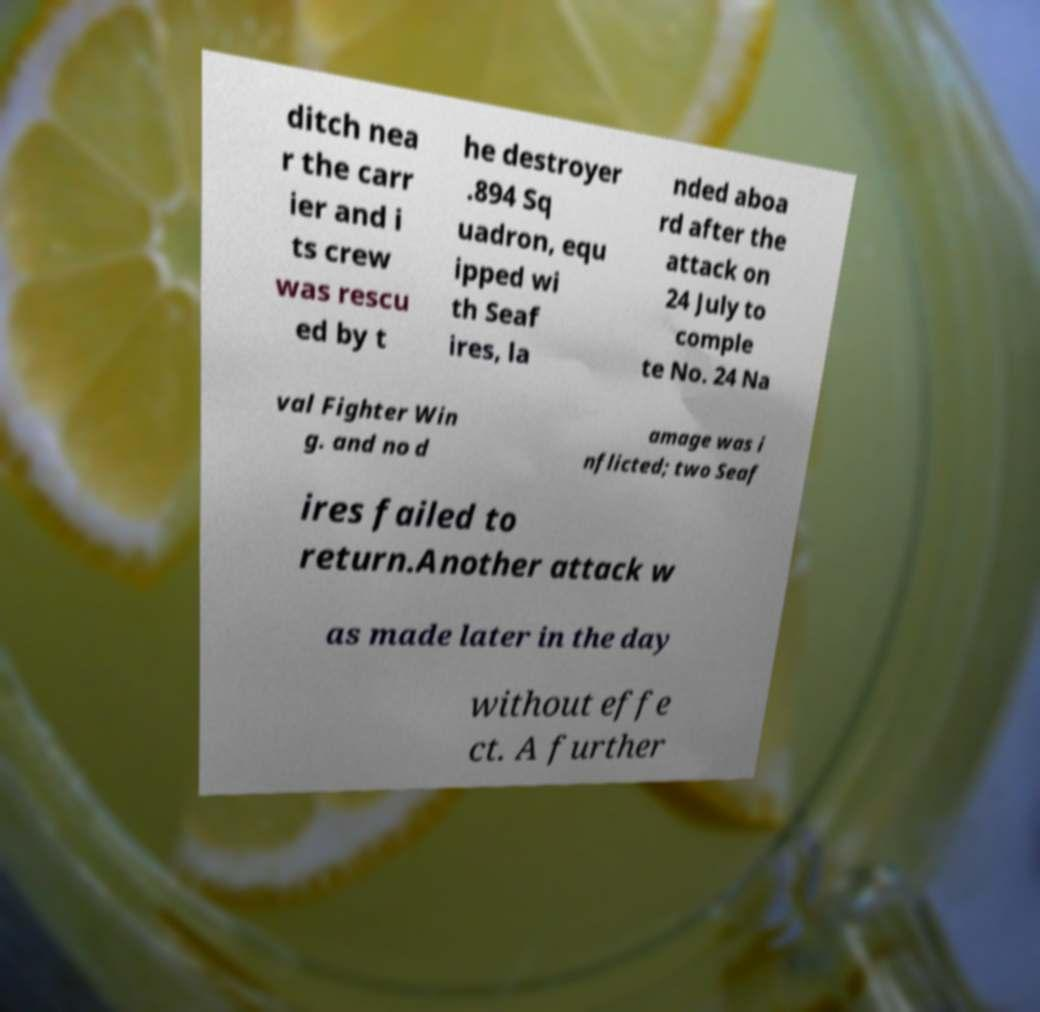Please identify and transcribe the text found in this image. ditch nea r the carr ier and i ts crew was rescu ed by t he destroyer .894 Sq uadron, equ ipped wi th Seaf ires, la nded aboa rd after the attack on 24 July to comple te No. 24 Na val Fighter Win g. and no d amage was i nflicted; two Seaf ires failed to return.Another attack w as made later in the day without effe ct. A further 